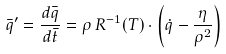Convert formula to latex. <formula><loc_0><loc_0><loc_500><loc_500>\bar { q } ^ { \prime } = \frac { d \bar { q } } { d \bar { t } } = \rho \, R ^ { - 1 } ( T ) \cdot \left ( \dot { q } - \frac { \eta } { \rho ^ { 2 } } \right )</formula> 